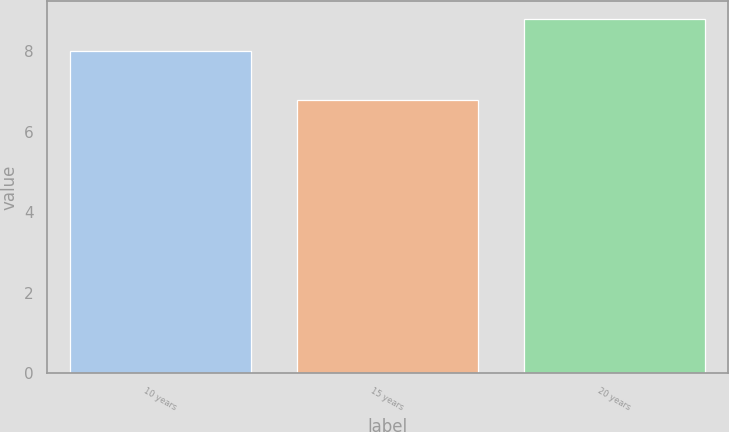Convert chart to OTSL. <chart><loc_0><loc_0><loc_500><loc_500><bar_chart><fcel>10 years<fcel>15 years<fcel>20 years<nl><fcel>8<fcel>6.8<fcel>8.8<nl></chart> 